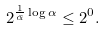Convert formula to latex. <formula><loc_0><loc_0><loc_500><loc_500>2 ^ { \frac { 1 } { \bar { \alpha } } \log \alpha } \leq 2 ^ { 0 } .</formula> 